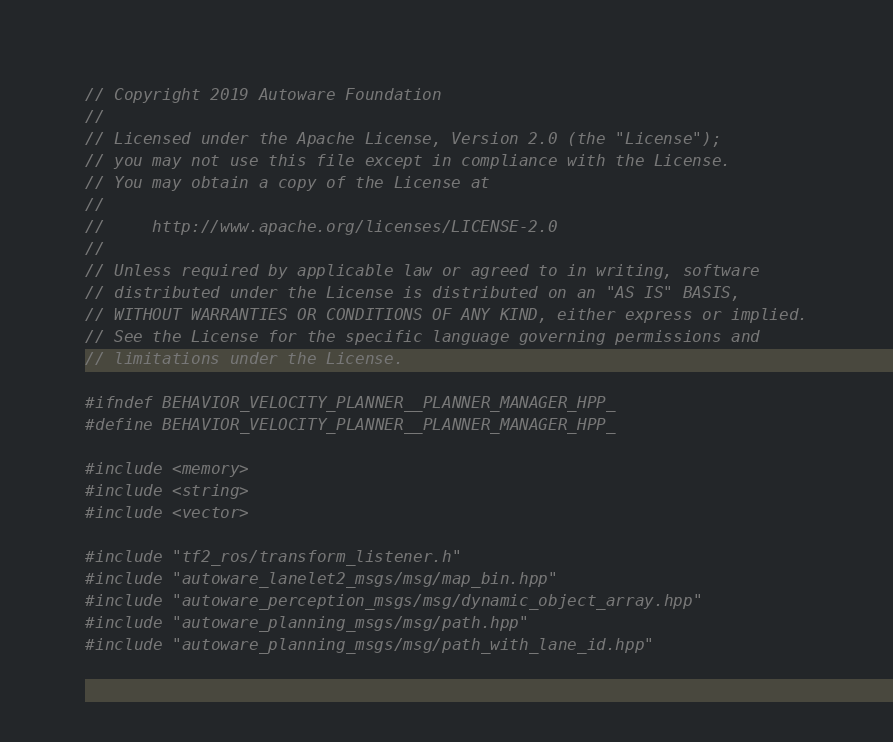Convert code to text. <code><loc_0><loc_0><loc_500><loc_500><_C++_>// Copyright 2019 Autoware Foundation
//
// Licensed under the Apache License, Version 2.0 (the "License");
// you may not use this file except in compliance with the License.
// You may obtain a copy of the License at
//
//     http://www.apache.org/licenses/LICENSE-2.0
//
// Unless required by applicable law or agreed to in writing, software
// distributed under the License is distributed on an "AS IS" BASIS,
// WITHOUT WARRANTIES OR CONDITIONS OF ANY KIND, either express or implied.
// See the License for the specific language governing permissions and
// limitations under the License.

#ifndef BEHAVIOR_VELOCITY_PLANNER__PLANNER_MANAGER_HPP_
#define BEHAVIOR_VELOCITY_PLANNER__PLANNER_MANAGER_HPP_

#include <memory>
#include <string>
#include <vector>

#include "tf2_ros/transform_listener.h"
#include "autoware_lanelet2_msgs/msg/map_bin.hpp"
#include "autoware_perception_msgs/msg/dynamic_object_array.hpp"
#include "autoware_planning_msgs/msg/path.hpp"
#include "autoware_planning_msgs/msg/path_with_lane_id.hpp"</code> 